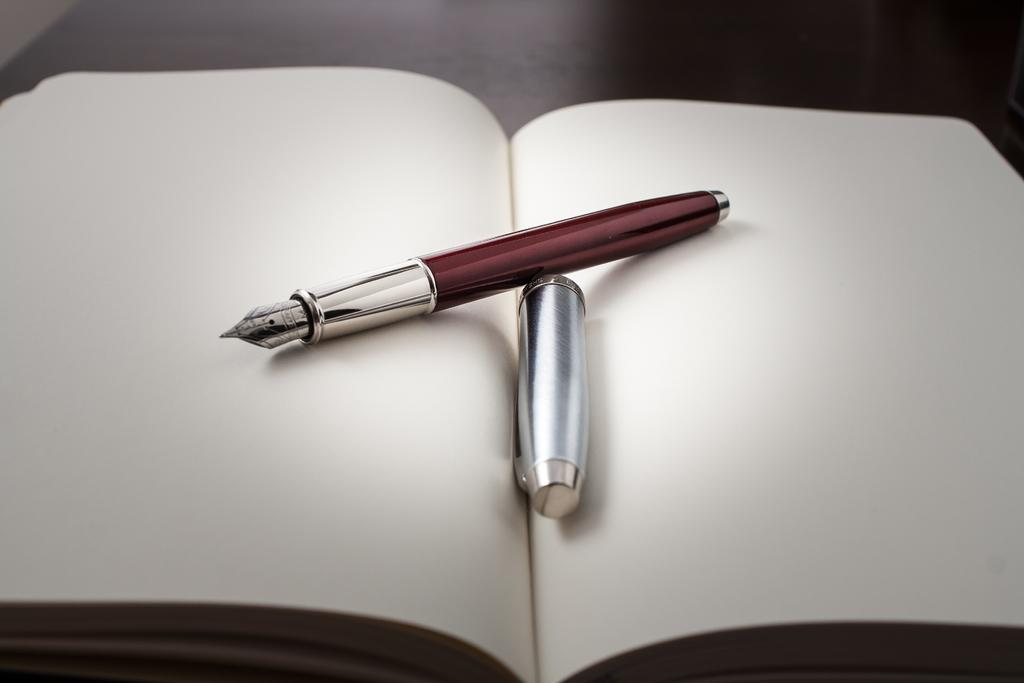What object is placed on the table in the image? There is a book on the table. What is placed on top of the book? There is a pen on the book on the book. Is there any other object on the book? Yes, there is a cap on the book. What type of beast can be seen roaming around in the image? There is no beast present in the image; it only features a book, a pen, and a cap. 